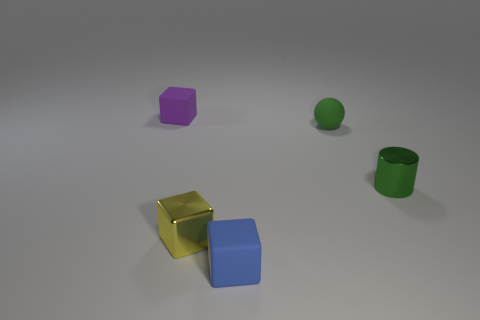There is a matte block that is to the left of the matte block in front of the purple matte thing; how big is it?
Keep it short and to the point. Small. Is there a cyan cylinder?
Give a very brief answer. No. There is a object that is both to the right of the yellow shiny block and in front of the metal cylinder; what is it made of?
Offer a very short reply. Rubber. Is the number of small yellow metallic things that are behind the yellow object greater than the number of tiny green cylinders that are right of the blue object?
Your answer should be very brief. No. Is there a blue cube of the same size as the green matte sphere?
Ensure brevity in your answer.  Yes. There is a yellow object in front of the green metal cylinder that is on the right side of the tiny rubber block to the right of the purple thing; what is its size?
Offer a very short reply. Small. The small cylinder is what color?
Make the answer very short. Green. Are there more green matte things on the right side of the tiny rubber ball than tiny green metal cylinders?
Keep it short and to the point. No. There is a small shiny cylinder; what number of tiny yellow metal cubes are left of it?
Offer a terse response. 1. There is a tiny rubber object that is the same color as the cylinder; what is its shape?
Ensure brevity in your answer.  Sphere. 